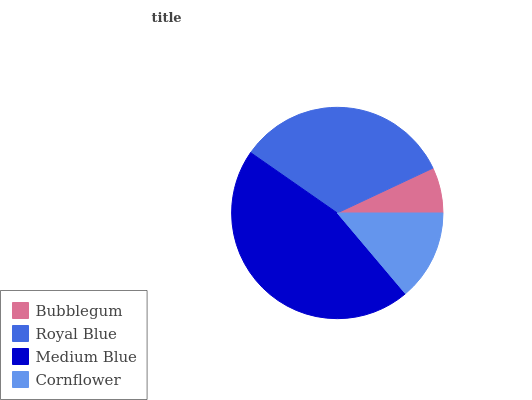Is Bubblegum the minimum?
Answer yes or no. Yes. Is Medium Blue the maximum?
Answer yes or no. Yes. Is Royal Blue the minimum?
Answer yes or no. No. Is Royal Blue the maximum?
Answer yes or no. No. Is Royal Blue greater than Bubblegum?
Answer yes or no. Yes. Is Bubblegum less than Royal Blue?
Answer yes or no. Yes. Is Bubblegum greater than Royal Blue?
Answer yes or no. No. Is Royal Blue less than Bubblegum?
Answer yes or no. No. Is Royal Blue the high median?
Answer yes or no. Yes. Is Cornflower the low median?
Answer yes or no. Yes. Is Medium Blue the high median?
Answer yes or no. No. Is Medium Blue the low median?
Answer yes or no. No. 